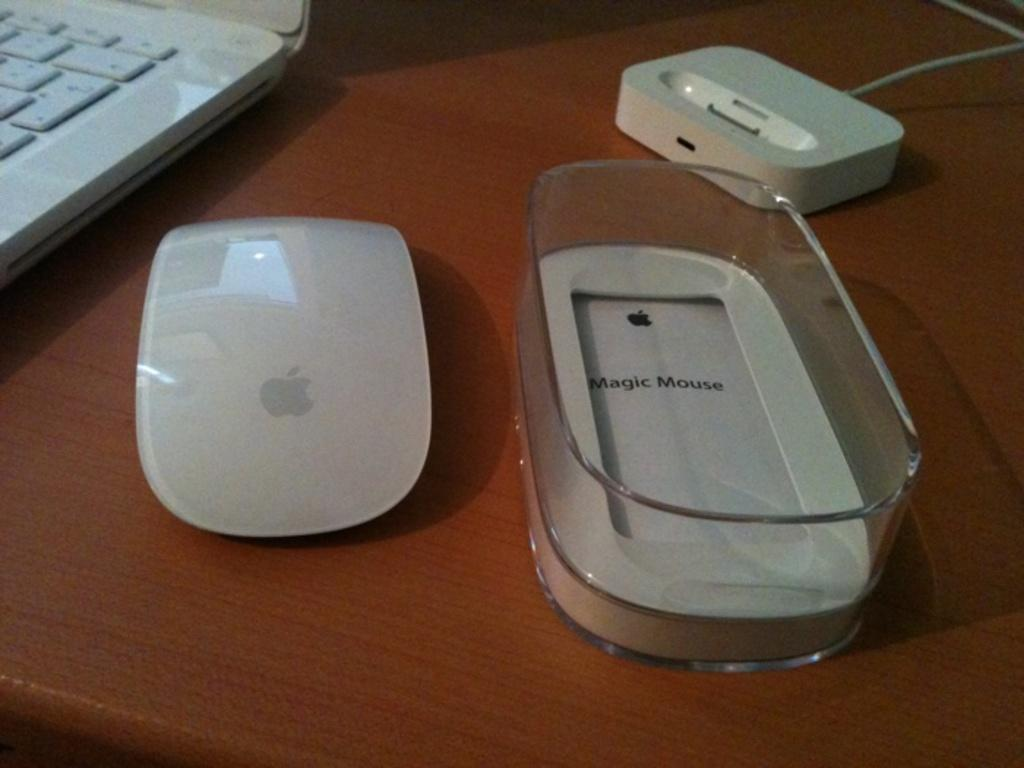What electronic device is visible in the image? There is a laptop in the image. What accessory is present for the laptop? There is a mouse in the image. What packaging is visible in the image? There is a magic mouse box in the image. What is the object on the table in the image? The object on the table is a laptop and a mouse. What type of cow can be seen grazing on the table in the image? There is no cow present in the image; it only features a laptop, a mouse, and a magic mouse box. 